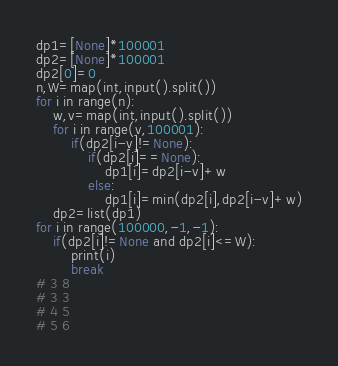Convert code to text. <code><loc_0><loc_0><loc_500><loc_500><_Python_>dp1=[None]*100001
dp2=[None]*100001
dp2[0]=0
n,W=map(int,input().split())
for i in range(n):
    w,v=map(int,input().split())
    for i in range(v,100001):
        if(dp2[i-v]!=None):
            if(dp2[i]==None):
                dp1[i]=dp2[i-v]+w
            else:
                dp1[i]=min(dp2[i],dp2[i-v]+w)
    dp2=list(dp1)
for i in range(100000,-1,-1):
    if(dp2[i]!=None and dp2[i]<=W):
        print(i)
        break
# 3 8
# 3 3
# 4 5
# 5 6</code> 